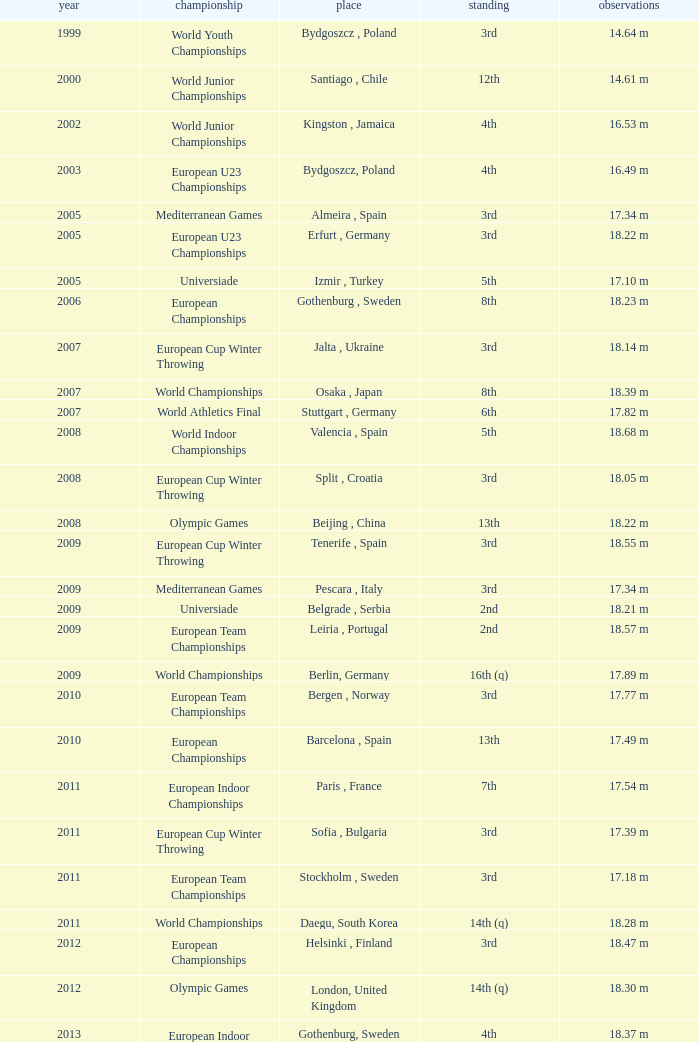Where were the Mediterranean games after 2005? Pescara , Italy. 